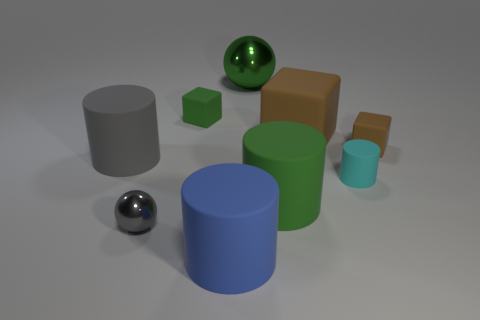What shape is the brown thing behind the matte block in front of the brown matte block left of the cyan rubber cylinder?
Make the answer very short. Cube. Are there an equal number of large metal balls in front of the small metallic sphere and brown matte things?
Offer a terse response. No. There is another thing that is the same color as the tiny metal thing; what size is it?
Ensure brevity in your answer.  Large. Is the shape of the small brown thing the same as the large brown thing?
Ensure brevity in your answer.  Yes. How many objects are either tiny matte things left of the tiny brown object or tiny cyan cylinders?
Ensure brevity in your answer.  2. Are there the same number of big blue rubber cylinders behind the tiny green thing and brown matte objects that are to the right of the gray metallic object?
Your answer should be compact. No. What number of other things are the same shape as the large green matte object?
Make the answer very short. 3. Is the size of the green thing left of the blue rubber cylinder the same as the gray object that is in front of the large gray matte cylinder?
Offer a terse response. Yes. What number of spheres are either small objects or small brown matte objects?
Your answer should be very brief. 1. How many metal things are either large blue objects or tiny brown spheres?
Provide a succinct answer. 0. 